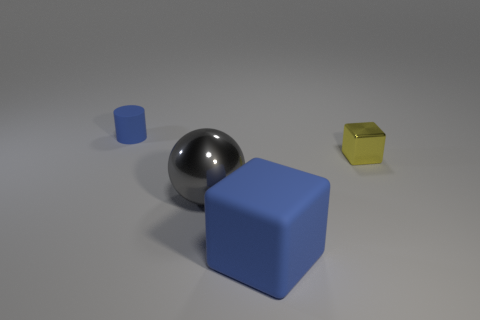There is a blue block that is the same size as the metal ball; what material is it?
Provide a succinct answer. Rubber. Is the material of the large blue object the same as the big gray sphere?
Ensure brevity in your answer.  No. What number of things are cylinders or gray things?
Ensure brevity in your answer.  2. What is the shape of the tiny metallic thing to the right of the big blue thing?
Offer a very short reply. Cube. What is the color of the thing that is the same material as the cylinder?
Make the answer very short. Blue. There is a blue object that is the same shape as the tiny yellow object; what is it made of?
Your answer should be very brief. Rubber. The big blue thing has what shape?
Keep it short and to the point. Cube. What is the thing that is to the right of the gray object and left of the tiny yellow metal thing made of?
Offer a very short reply. Rubber. The big thing that is made of the same material as the blue cylinder is what shape?
Your answer should be compact. Cube. The blue block that is made of the same material as the small cylinder is what size?
Offer a very short reply. Large. 